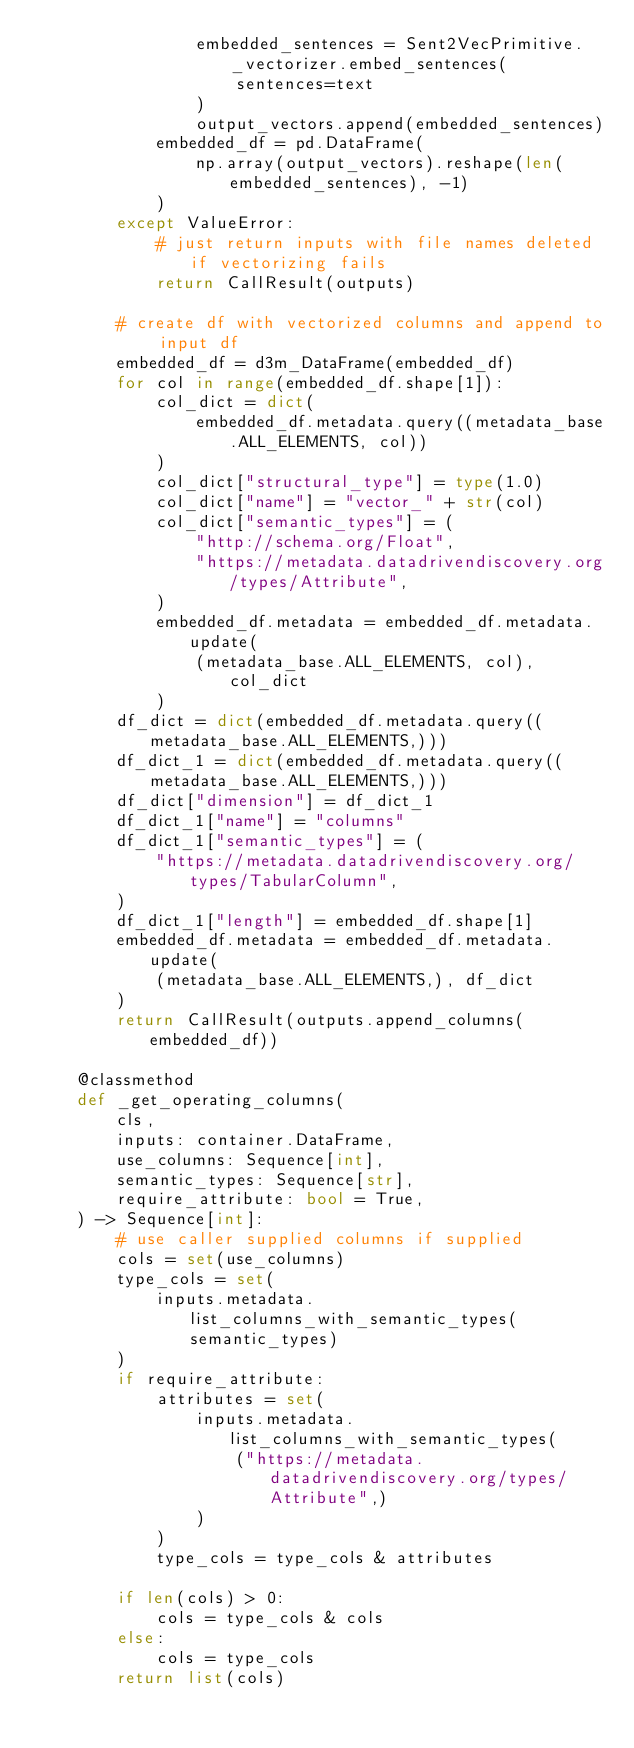<code> <loc_0><loc_0><loc_500><loc_500><_Python_>                embedded_sentences = Sent2VecPrimitive._vectorizer.embed_sentences(
                    sentences=text
                )
                output_vectors.append(embedded_sentences)
            embedded_df = pd.DataFrame(
                np.array(output_vectors).reshape(len(embedded_sentences), -1)
            )
        except ValueError:
            # just return inputs with file names deleted if vectorizing fails
            return CallResult(outputs)

        # create df with vectorized columns and append to input df
        embedded_df = d3m_DataFrame(embedded_df)
        for col in range(embedded_df.shape[1]):
            col_dict = dict(
                embedded_df.metadata.query((metadata_base.ALL_ELEMENTS, col))
            )
            col_dict["structural_type"] = type(1.0)
            col_dict["name"] = "vector_" + str(col)
            col_dict["semantic_types"] = (
                "http://schema.org/Float",
                "https://metadata.datadrivendiscovery.org/types/Attribute",
            )
            embedded_df.metadata = embedded_df.metadata.update(
                (metadata_base.ALL_ELEMENTS, col), col_dict
            )
        df_dict = dict(embedded_df.metadata.query((metadata_base.ALL_ELEMENTS,)))
        df_dict_1 = dict(embedded_df.metadata.query((metadata_base.ALL_ELEMENTS,)))
        df_dict["dimension"] = df_dict_1
        df_dict_1["name"] = "columns"
        df_dict_1["semantic_types"] = (
            "https://metadata.datadrivendiscovery.org/types/TabularColumn",
        )
        df_dict_1["length"] = embedded_df.shape[1]
        embedded_df.metadata = embedded_df.metadata.update(
            (metadata_base.ALL_ELEMENTS,), df_dict
        )
        return CallResult(outputs.append_columns(embedded_df))

    @classmethod
    def _get_operating_columns(
        cls,
        inputs: container.DataFrame,
        use_columns: Sequence[int],
        semantic_types: Sequence[str],
        require_attribute: bool = True,
    ) -> Sequence[int]:
        # use caller supplied columns if supplied
        cols = set(use_columns)
        type_cols = set(
            inputs.metadata.list_columns_with_semantic_types(semantic_types)
        )
        if require_attribute:
            attributes = set(
                inputs.metadata.list_columns_with_semantic_types(
                    ("https://metadata.datadrivendiscovery.org/types/Attribute",)
                )
            )
            type_cols = type_cols & attributes

        if len(cols) > 0:
            cols = type_cols & cols
        else:
            cols = type_cols
        return list(cols)</code> 